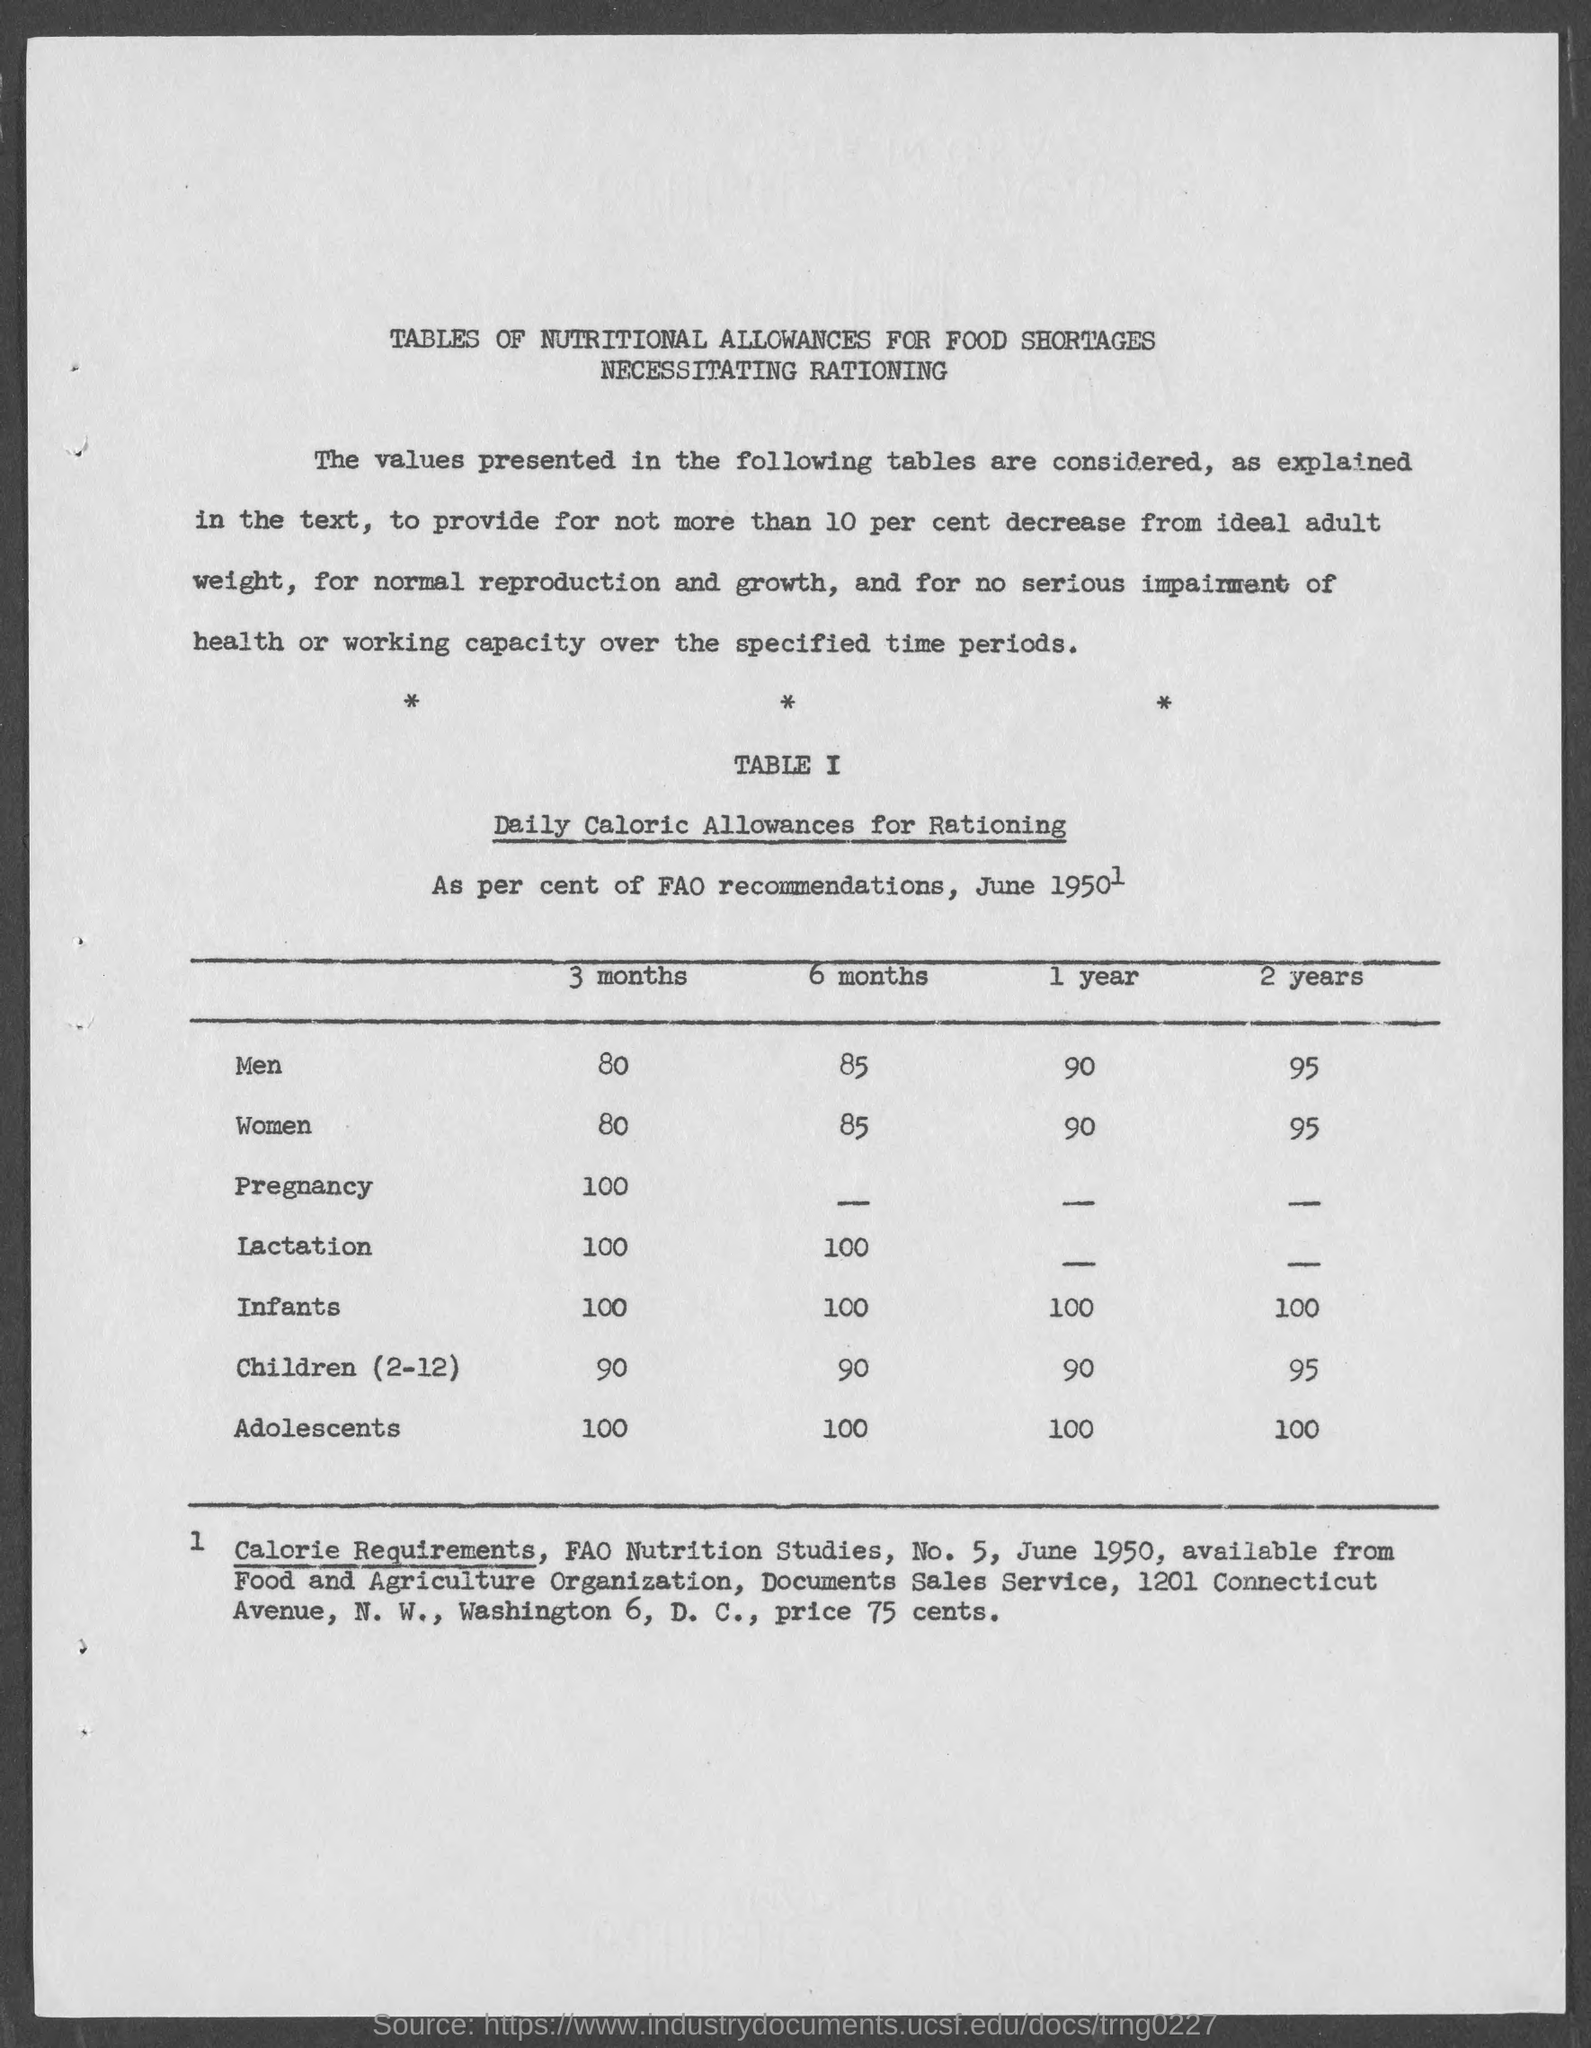List a handful of essential elements in this visual. The daily calorie allowances for rationing for women for 1 year is 90 calories. What is the daily calorie allowance for rationing for lactation for three months? 100.. The daily calorie allowances for rationing for women for six months are 85 calories per day. The daily calorie allowance for rationing during pregnancy for three months is 100 calories. The daily calorie allowances for rationing for men for two years is 95. 